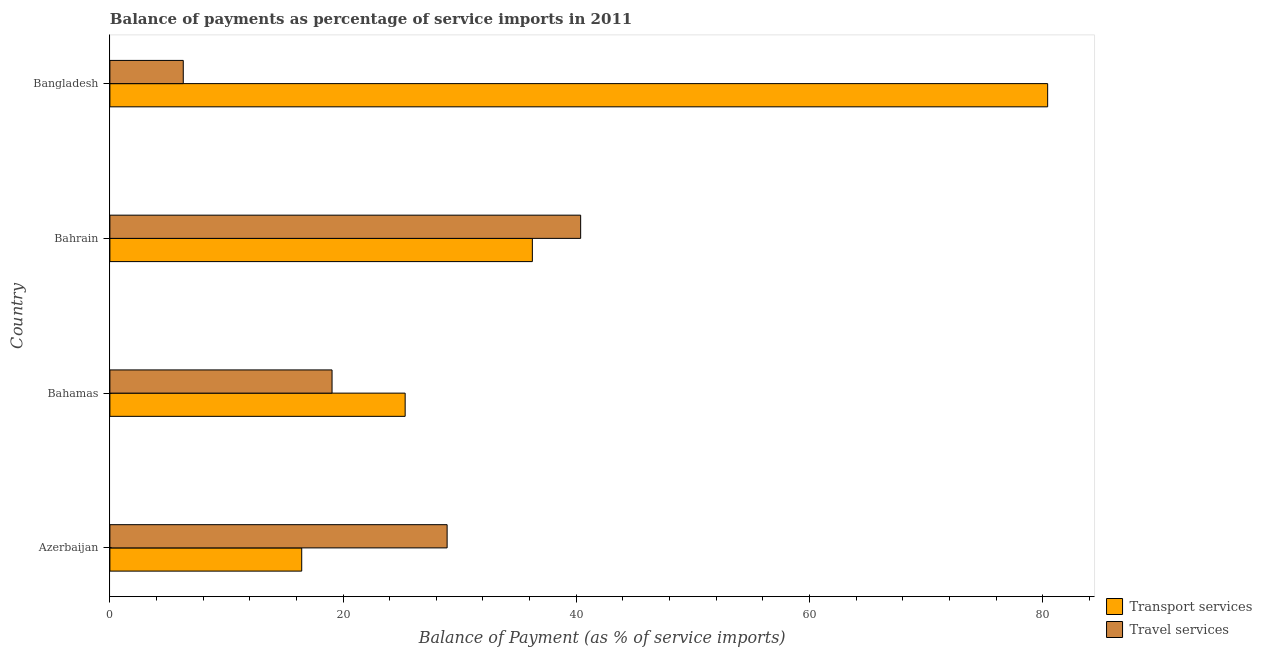Are the number of bars on each tick of the Y-axis equal?
Your answer should be compact. Yes. What is the label of the 3rd group of bars from the top?
Give a very brief answer. Bahamas. What is the balance of payments of travel services in Bahrain?
Offer a very short reply. 40.38. Across all countries, what is the maximum balance of payments of transport services?
Make the answer very short. 80.43. Across all countries, what is the minimum balance of payments of travel services?
Your answer should be compact. 6.29. In which country was the balance of payments of travel services maximum?
Give a very brief answer. Bahrain. In which country was the balance of payments of travel services minimum?
Offer a very short reply. Bangladesh. What is the total balance of payments of travel services in the graph?
Give a very brief answer. 94.65. What is the difference between the balance of payments of travel services in Bahrain and that in Bangladesh?
Your answer should be very brief. 34.08. What is the difference between the balance of payments of travel services in Bangladesh and the balance of payments of transport services in Azerbaijan?
Offer a terse response. -10.16. What is the average balance of payments of travel services per country?
Your answer should be compact. 23.66. What is the difference between the balance of payments of travel services and balance of payments of transport services in Bahrain?
Your answer should be very brief. 4.14. In how many countries, is the balance of payments of travel services greater than 16 %?
Provide a short and direct response. 3. What is the ratio of the balance of payments of transport services in Bahamas to that in Bangladesh?
Make the answer very short. 0.32. Is the balance of payments of transport services in Bahamas less than that in Bahrain?
Ensure brevity in your answer.  Yes. Is the difference between the balance of payments of transport services in Bahamas and Bahrain greater than the difference between the balance of payments of travel services in Bahamas and Bahrain?
Offer a very short reply. Yes. What is the difference between the highest and the second highest balance of payments of transport services?
Make the answer very short. 44.2. What is the difference between the highest and the lowest balance of payments of travel services?
Offer a terse response. 34.08. In how many countries, is the balance of payments of travel services greater than the average balance of payments of travel services taken over all countries?
Your response must be concise. 2. Is the sum of the balance of payments of travel services in Azerbaijan and Bahamas greater than the maximum balance of payments of transport services across all countries?
Offer a very short reply. No. What does the 1st bar from the top in Azerbaijan represents?
Your response must be concise. Travel services. What does the 1st bar from the bottom in Azerbaijan represents?
Your answer should be compact. Transport services. Are all the bars in the graph horizontal?
Provide a succinct answer. Yes. How many countries are there in the graph?
Offer a terse response. 4. What is the difference between two consecutive major ticks on the X-axis?
Make the answer very short. 20. Are the values on the major ticks of X-axis written in scientific E-notation?
Ensure brevity in your answer.  No. Does the graph contain any zero values?
Keep it short and to the point. No. Does the graph contain grids?
Make the answer very short. No. How many legend labels are there?
Your answer should be very brief. 2. What is the title of the graph?
Provide a succinct answer. Balance of payments as percentage of service imports in 2011. Does "National Visitors" appear as one of the legend labels in the graph?
Your response must be concise. No. What is the label or title of the X-axis?
Your response must be concise. Balance of Payment (as % of service imports). What is the label or title of the Y-axis?
Your answer should be compact. Country. What is the Balance of Payment (as % of service imports) of Transport services in Azerbaijan?
Make the answer very short. 16.45. What is the Balance of Payment (as % of service imports) in Travel services in Azerbaijan?
Your response must be concise. 28.92. What is the Balance of Payment (as % of service imports) of Transport services in Bahamas?
Your answer should be very brief. 25.32. What is the Balance of Payment (as % of service imports) in Travel services in Bahamas?
Provide a succinct answer. 19.05. What is the Balance of Payment (as % of service imports) in Transport services in Bahrain?
Provide a short and direct response. 36.23. What is the Balance of Payment (as % of service imports) of Travel services in Bahrain?
Provide a succinct answer. 40.38. What is the Balance of Payment (as % of service imports) of Transport services in Bangladesh?
Keep it short and to the point. 80.43. What is the Balance of Payment (as % of service imports) of Travel services in Bangladesh?
Make the answer very short. 6.29. Across all countries, what is the maximum Balance of Payment (as % of service imports) in Transport services?
Your answer should be very brief. 80.43. Across all countries, what is the maximum Balance of Payment (as % of service imports) in Travel services?
Offer a very short reply. 40.38. Across all countries, what is the minimum Balance of Payment (as % of service imports) in Transport services?
Give a very brief answer. 16.45. Across all countries, what is the minimum Balance of Payment (as % of service imports) in Travel services?
Your answer should be compact. 6.29. What is the total Balance of Payment (as % of service imports) of Transport services in the graph?
Your answer should be very brief. 158.44. What is the total Balance of Payment (as % of service imports) of Travel services in the graph?
Provide a short and direct response. 94.65. What is the difference between the Balance of Payment (as % of service imports) of Transport services in Azerbaijan and that in Bahamas?
Provide a short and direct response. -8.87. What is the difference between the Balance of Payment (as % of service imports) in Travel services in Azerbaijan and that in Bahamas?
Ensure brevity in your answer.  9.87. What is the difference between the Balance of Payment (as % of service imports) of Transport services in Azerbaijan and that in Bahrain?
Give a very brief answer. -19.78. What is the difference between the Balance of Payment (as % of service imports) of Travel services in Azerbaijan and that in Bahrain?
Your answer should be compact. -11.45. What is the difference between the Balance of Payment (as % of service imports) in Transport services in Azerbaijan and that in Bangladesh?
Offer a terse response. -63.98. What is the difference between the Balance of Payment (as % of service imports) in Travel services in Azerbaijan and that in Bangladesh?
Your answer should be compact. 22.63. What is the difference between the Balance of Payment (as % of service imports) of Transport services in Bahamas and that in Bahrain?
Provide a succinct answer. -10.91. What is the difference between the Balance of Payment (as % of service imports) in Travel services in Bahamas and that in Bahrain?
Your answer should be very brief. -21.32. What is the difference between the Balance of Payment (as % of service imports) in Transport services in Bahamas and that in Bangladesh?
Make the answer very short. -55.1. What is the difference between the Balance of Payment (as % of service imports) of Travel services in Bahamas and that in Bangladesh?
Keep it short and to the point. 12.76. What is the difference between the Balance of Payment (as % of service imports) of Transport services in Bahrain and that in Bangladesh?
Ensure brevity in your answer.  -44.2. What is the difference between the Balance of Payment (as % of service imports) in Travel services in Bahrain and that in Bangladesh?
Your answer should be compact. 34.08. What is the difference between the Balance of Payment (as % of service imports) in Transport services in Azerbaijan and the Balance of Payment (as % of service imports) in Travel services in Bahamas?
Offer a very short reply. -2.6. What is the difference between the Balance of Payment (as % of service imports) of Transport services in Azerbaijan and the Balance of Payment (as % of service imports) of Travel services in Bahrain?
Offer a very short reply. -23.92. What is the difference between the Balance of Payment (as % of service imports) of Transport services in Azerbaijan and the Balance of Payment (as % of service imports) of Travel services in Bangladesh?
Your answer should be compact. 10.16. What is the difference between the Balance of Payment (as % of service imports) of Transport services in Bahamas and the Balance of Payment (as % of service imports) of Travel services in Bahrain?
Ensure brevity in your answer.  -15.05. What is the difference between the Balance of Payment (as % of service imports) of Transport services in Bahamas and the Balance of Payment (as % of service imports) of Travel services in Bangladesh?
Keep it short and to the point. 19.03. What is the difference between the Balance of Payment (as % of service imports) of Transport services in Bahrain and the Balance of Payment (as % of service imports) of Travel services in Bangladesh?
Make the answer very short. 29.94. What is the average Balance of Payment (as % of service imports) in Transport services per country?
Your answer should be compact. 39.61. What is the average Balance of Payment (as % of service imports) in Travel services per country?
Ensure brevity in your answer.  23.66. What is the difference between the Balance of Payment (as % of service imports) of Transport services and Balance of Payment (as % of service imports) of Travel services in Azerbaijan?
Your response must be concise. -12.47. What is the difference between the Balance of Payment (as % of service imports) of Transport services and Balance of Payment (as % of service imports) of Travel services in Bahamas?
Your answer should be compact. 6.27. What is the difference between the Balance of Payment (as % of service imports) in Transport services and Balance of Payment (as % of service imports) in Travel services in Bahrain?
Your response must be concise. -4.14. What is the difference between the Balance of Payment (as % of service imports) of Transport services and Balance of Payment (as % of service imports) of Travel services in Bangladesh?
Your response must be concise. 74.14. What is the ratio of the Balance of Payment (as % of service imports) of Transport services in Azerbaijan to that in Bahamas?
Provide a short and direct response. 0.65. What is the ratio of the Balance of Payment (as % of service imports) of Travel services in Azerbaijan to that in Bahamas?
Make the answer very short. 1.52. What is the ratio of the Balance of Payment (as % of service imports) in Transport services in Azerbaijan to that in Bahrain?
Make the answer very short. 0.45. What is the ratio of the Balance of Payment (as % of service imports) in Travel services in Azerbaijan to that in Bahrain?
Your response must be concise. 0.72. What is the ratio of the Balance of Payment (as % of service imports) of Transport services in Azerbaijan to that in Bangladesh?
Make the answer very short. 0.2. What is the ratio of the Balance of Payment (as % of service imports) of Travel services in Azerbaijan to that in Bangladesh?
Provide a succinct answer. 4.6. What is the ratio of the Balance of Payment (as % of service imports) of Transport services in Bahamas to that in Bahrain?
Make the answer very short. 0.7. What is the ratio of the Balance of Payment (as % of service imports) in Travel services in Bahamas to that in Bahrain?
Your answer should be very brief. 0.47. What is the ratio of the Balance of Payment (as % of service imports) of Transport services in Bahamas to that in Bangladesh?
Give a very brief answer. 0.31. What is the ratio of the Balance of Payment (as % of service imports) in Travel services in Bahamas to that in Bangladesh?
Offer a very short reply. 3.03. What is the ratio of the Balance of Payment (as % of service imports) of Transport services in Bahrain to that in Bangladesh?
Ensure brevity in your answer.  0.45. What is the ratio of the Balance of Payment (as % of service imports) in Travel services in Bahrain to that in Bangladesh?
Provide a short and direct response. 6.42. What is the difference between the highest and the second highest Balance of Payment (as % of service imports) of Transport services?
Provide a short and direct response. 44.2. What is the difference between the highest and the second highest Balance of Payment (as % of service imports) in Travel services?
Provide a short and direct response. 11.45. What is the difference between the highest and the lowest Balance of Payment (as % of service imports) in Transport services?
Your response must be concise. 63.98. What is the difference between the highest and the lowest Balance of Payment (as % of service imports) in Travel services?
Give a very brief answer. 34.08. 